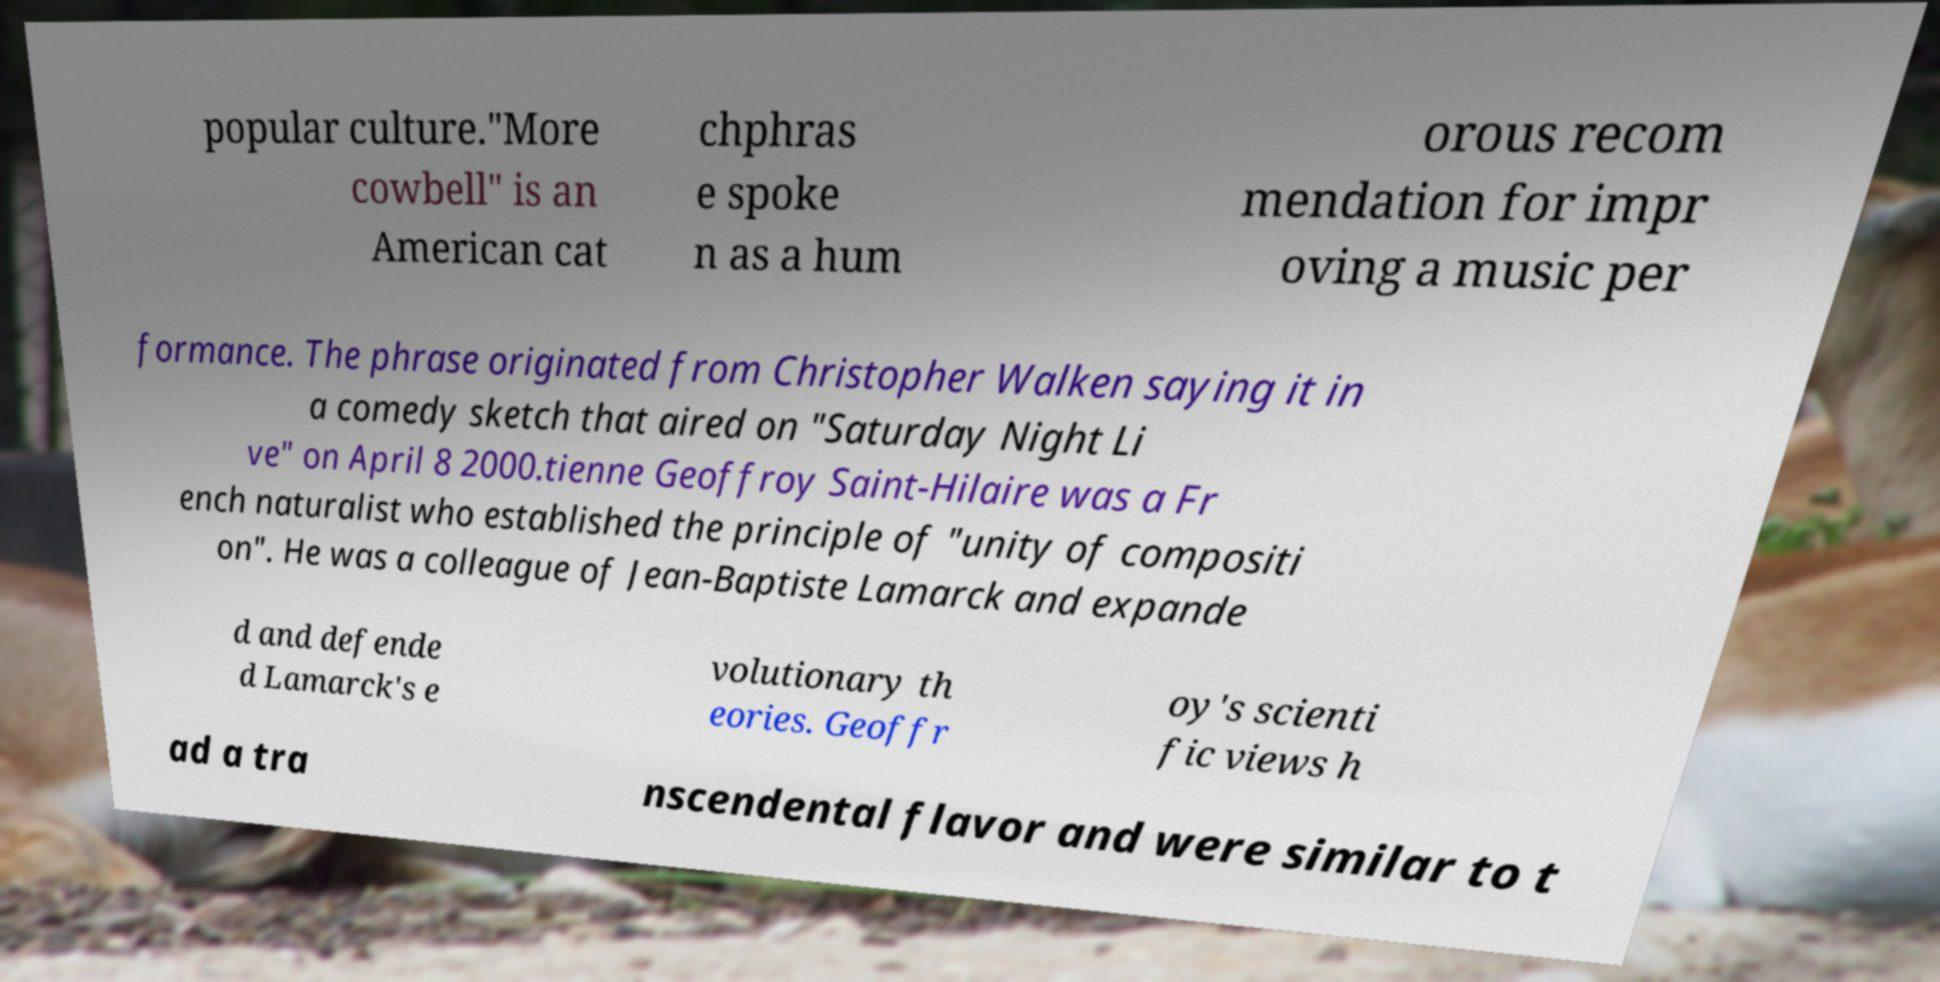I need the written content from this picture converted into text. Can you do that? popular culture."More cowbell" is an American cat chphras e spoke n as a hum orous recom mendation for impr oving a music per formance. The phrase originated from Christopher Walken saying it in a comedy sketch that aired on "Saturday Night Li ve" on April 8 2000.tienne Geoffroy Saint-Hilaire was a Fr ench naturalist who established the principle of "unity of compositi on". He was a colleague of Jean-Baptiste Lamarck and expande d and defende d Lamarck's e volutionary th eories. Geoffr oy's scienti fic views h ad a tra nscendental flavor and were similar to t 